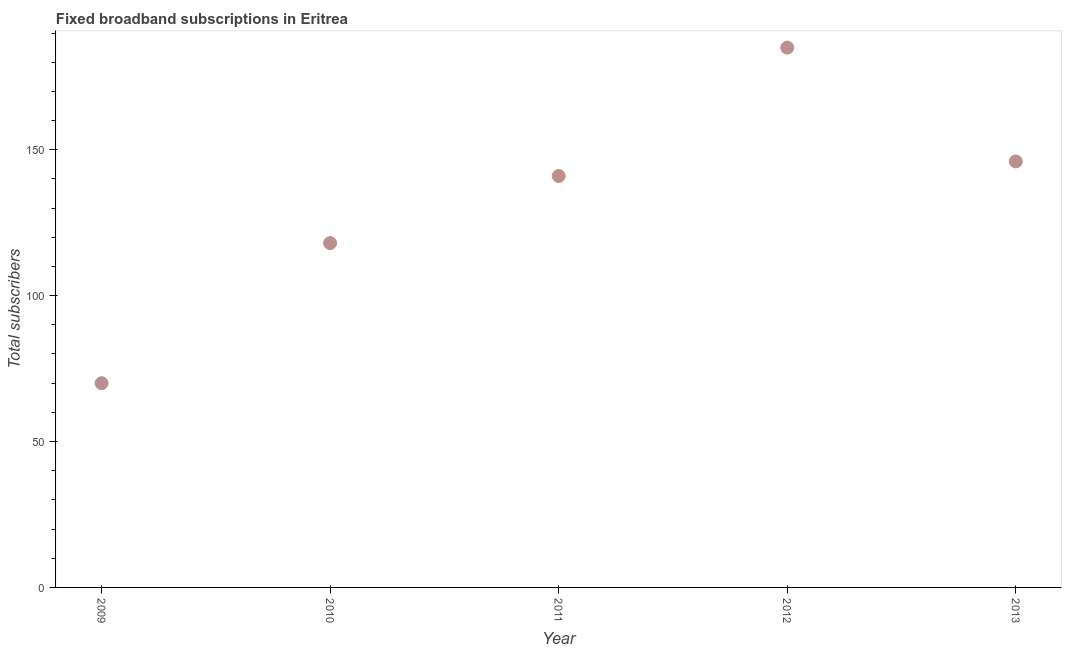What is the total number of fixed broadband subscriptions in 2013?
Keep it short and to the point. 146. Across all years, what is the maximum total number of fixed broadband subscriptions?
Keep it short and to the point. 185. Across all years, what is the minimum total number of fixed broadband subscriptions?
Your answer should be compact. 70. What is the sum of the total number of fixed broadband subscriptions?
Give a very brief answer. 660. What is the difference between the total number of fixed broadband subscriptions in 2009 and 2010?
Your answer should be compact. -48. What is the average total number of fixed broadband subscriptions per year?
Give a very brief answer. 132. What is the median total number of fixed broadband subscriptions?
Provide a succinct answer. 141. In how many years, is the total number of fixed broadband subscriptions greater than 40 ?
Keep it short and to the point. 5. What is the ratio of the total number of fixed broadband subscriptions in 2012 to that in 2013?
Keep it short and to the point. 1.27. Is the total number of fixed broadband subscriptions in 2010 less than that in 2011?
Your answer should be very brief. Yes. What is the difference between the highest and the second highest total number of fixed broadband subscriptions?
Offer a terse response. 39. Is the sum of the total number of fixed broadband subscriptions in 2012 and 2013 greater than the maximum total number of fixed broadband subscriptions across all years?
Provide a succinct answer. Yes. What is the difference between the highest and the lowest total number of fixed broadband subscriptions?
Your answer should be very brief. 115. How many dotlines are there?
Keep it short and to the point. 1. Are the values on the major ticks of Y-axis written in scientific E-notation?
Your response must be concise. No. What is the title of the graph?
Provide a succinct answer. Fixed broadband subscriptions in Eritrea. What is the label or title of the Y-axis?
Provide a succinct answer. Total subscribers. What is the Total subscribers in 2009?
Provide a short and direct response. 70. What is the Total subscribers in 2010?
Offer a terse response. 118. What is the Total subscribers in 2011?
Provide a succinct answer. 141. What is the Total subscribers in 2012?
Provide a short and direct response. 185. What is the Total subscribers in 2013?
Give a very brief answer. 146. What is the difference between the Total subscribers in 2009 and 2010?
Offer a terse response. -48. What is the difference between the Total subscribers in 2009 and 2011?
Make the answer very short. -71. What is the difference between the Total subscribers in 2009 and 2012?
Provide a succinct answer. -115. What is the difference between the Total subscribers in 2009 and 2013?
Keep it short and to the point. -76. What is the difference between the Total subscribers in 2010 and 2011?
Your answer should be very brief. -23. What is the difference between the Total subscribers in 2010 and 2012?
Ensure brevity in your answer.  -67. What is the difference between the Total subscribers in 2011 and 2012?
Your answer should be very brief. -44. What is the difference between the Total subscribers in 2012 and 2013?
Offer a terse response. 39. What is the ratio of the Total subscribers in 2009 to that in 2010?
Make the answer very short. 0.59. What is the ratio of the Total subscribers in 2009 to that in 2011?
Your answer should be very brief. 0.5. What is the ratio of the Total subscribers in 2009 to that in 2012?
Ensure brevity in your answer.  0.38. What is the ratio of the Total subscribers in 2009 to that in 2013?
Keep it short and to the point. 0.48. What is the ratio of the Total subscribers in 2010 to that in 2011?
Offer a terse response. 0.84. What is the ratio of the Total subscribers in 2010 to that in 2012?
Provide a succinct answer. 0.64. What is the ratio of the Total subscribers in 2010 to that in 2013?
Your response must be concise. 0.81. What is the ratio of the Total subscribers in 2011 to that in 2012?
Keep it short and to the point. 0.76. What is the ratio of the Total subscribers in 2011 to that in 2013?
Give a very brief answer. 0.97. What is the ratio of the Total subscribers in 2012 to that in 2013?
Offer a very short reply. 1.27. 